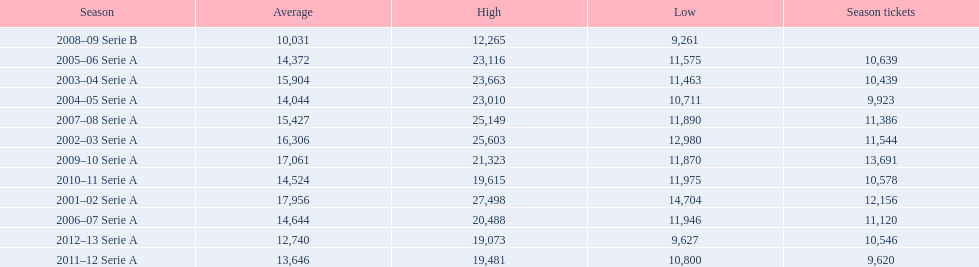What are the seasons? 2001–02 Serie A, 2002–03 Serie A, 2003–04 Serie A, 2004–05 Serie A, 2005–06 Serie A, 2006–07 Serie A, 2007–08 Serie A, 2008–09 Serie B, 2009–10 Serie A, 2010–11 Serie A, 2011–12 Serie A, 2012–13 Serie A. Which season is in 2007? 2007–08 Serie A. How many season tickets were sold that season? 11,386. 